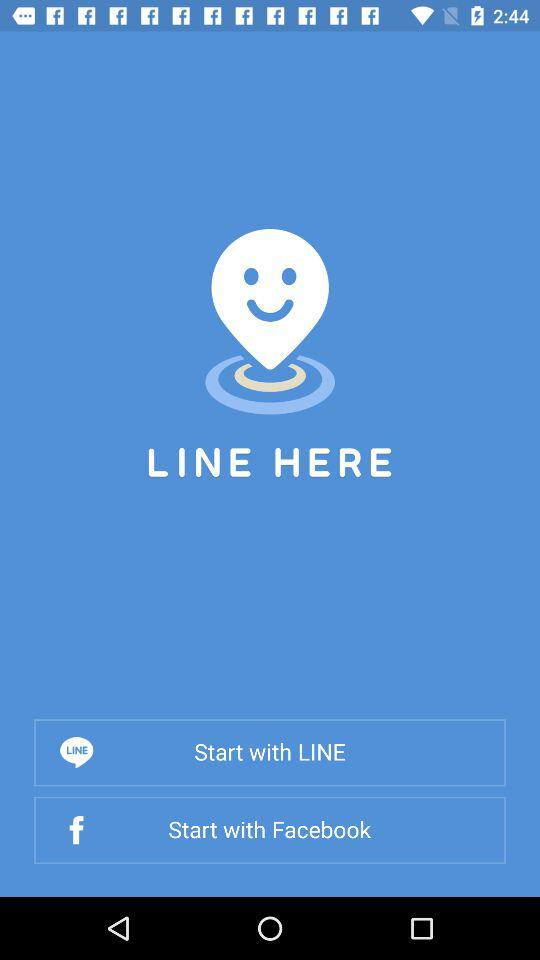What is the name of the application? The name of the application is "LINE HERE". 